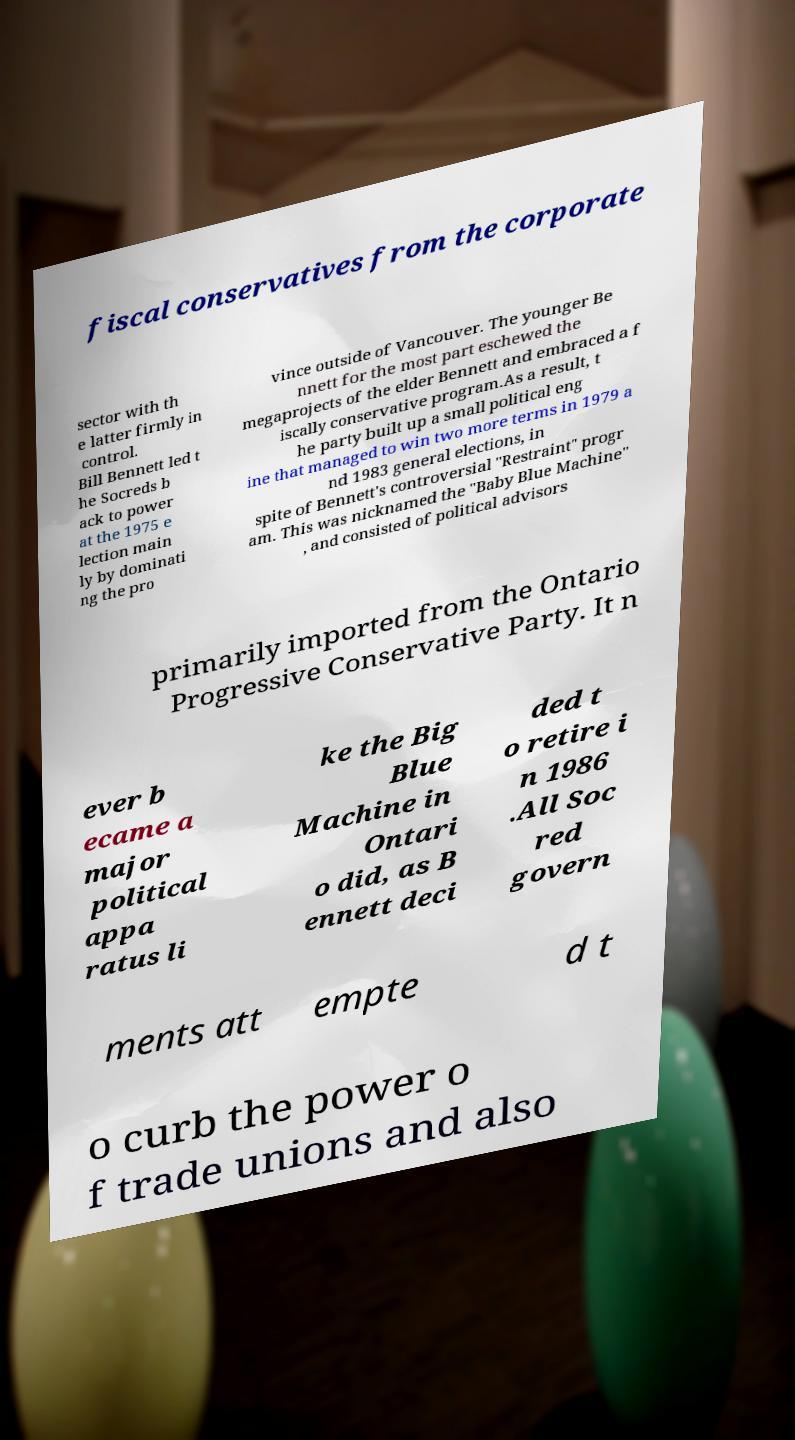For documentation purposes, I need the text within this image transcribed. Could you provide that? fiscal conservatives from the corporate sector with th e latter firmly in control. Bill Bennett led t he Socreds b ack to power at the 1975 e lection main ly by dominati ng the pro vince outside of Vancouver. The younger Be nnett for the most part eschewed the megaprojects of the elder Bennett and embraced a f iscally conservative program.As a result, t he party built up a small political eng ine that managed to win two more terms in 1979 a nd 1983 general elections, in spite of Bennett's controversial "Restraint" progr am. This was nicknamed the "Baby Blue Machine" , and consisted of political advisors primarily imported from the Ontario Progressive Conservative Party. It n ever b ecame a major political appa ratus li ke the Big Blue Machine in Ontari o did, as B ennett deci ded t o retire i n 1986 .All Soc red govern ments att empte d t o curb the power o f trade unions and also 